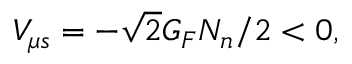<formula> <loc_0><loc_0><loc_500><loc_500>V _ { \mu s } = - \sqrt { 2 } G _ { F } N _ { n } / 2 < 0 ,</formula> 